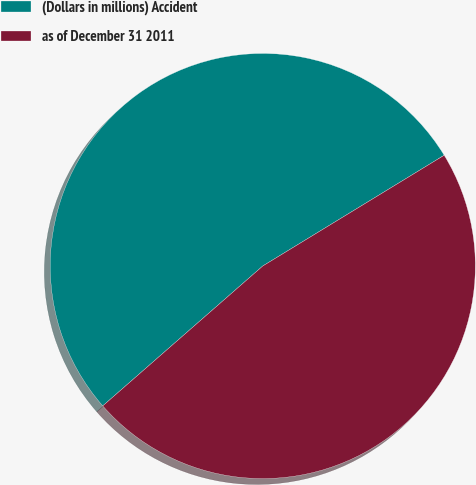Convert chart to OTSL. <chart><loc_0><loc_0><loc_500><loc_500><pie_chart><fcel>(Dollars in millions) Accident<fcel>as of December 31 2011<nl><fcel>52.71%<fcel>47.29%<nl></chart> 